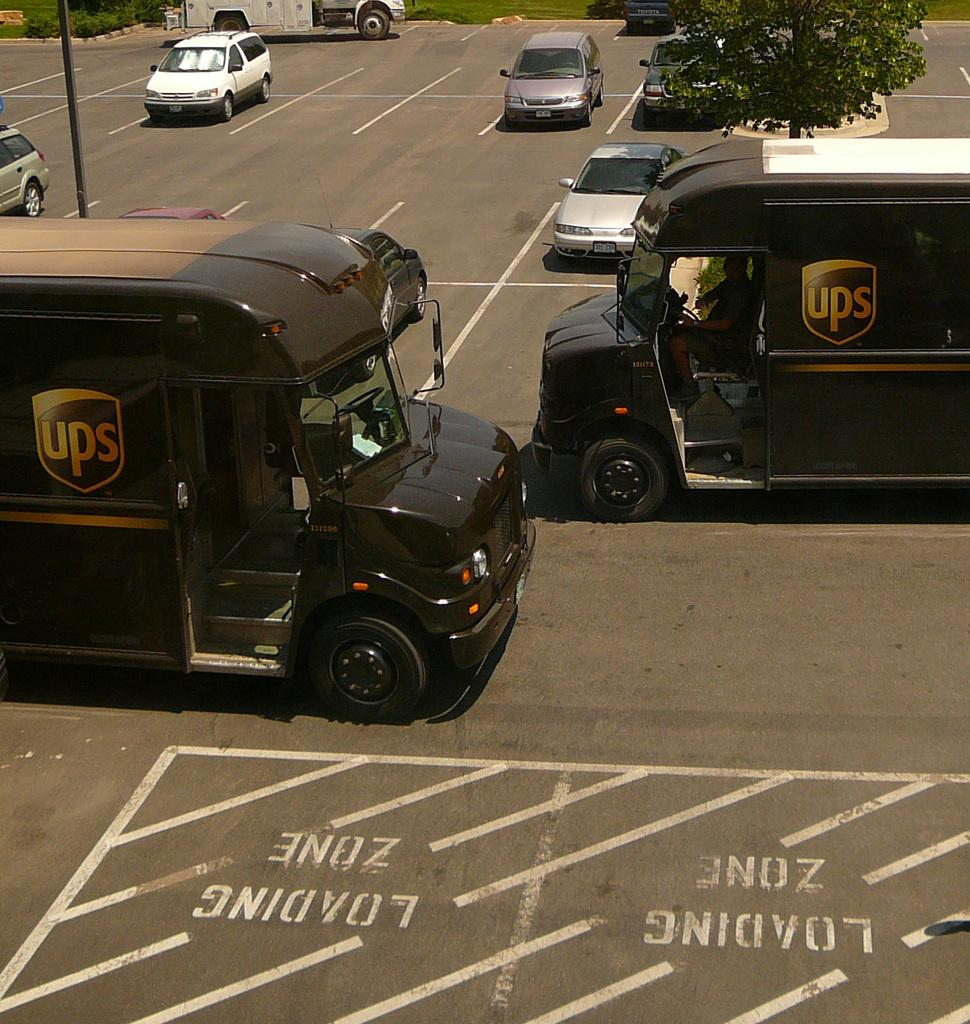How many vehicles can be seen in the image? There are two black color vehicles in the image. What are the vehicles doing in the image? The vehicles are moving on the road. What can be seen on the right side of the image? There is a tree on the right side of the image. What is happening on the left side of the road in the image? There are cars moving on the left side of the road in the image. What type of linen is draped over the arm of the driver in the image? There are no drivers or arms visible in the image; it only shows vehicles moving on the road. 